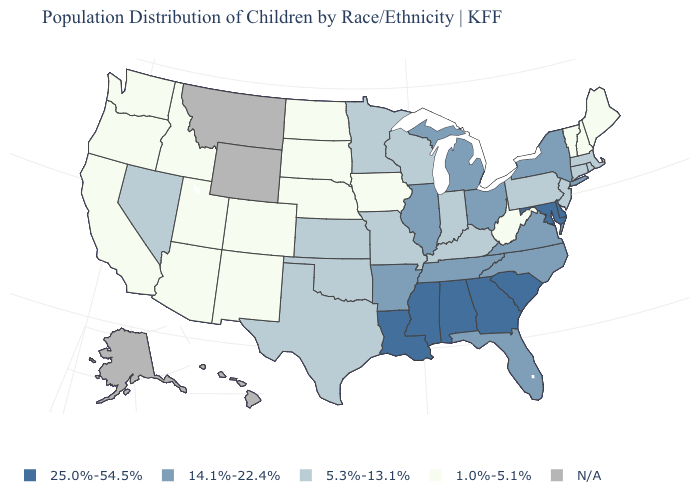What is the highest value in the West ?
Be succinct. 5.3%-13.1%. Name the states that have a value in the range 25.0%-54.5%?
Concise answer only. Alabama, Delaware, Georgia, Louisiana, Maryland, Mississippi, South Carolina. Which states have the highest value in the USA?
Write a very short answer. Alabama, Delaware, Georgia, Louisiana, Maryland, Mississippi, South Carolina. How many symbols are there in the legend?
Keep it brief. 5. What is the value of Oklahoma?
Answer briefly. 5.3%-13.1%. Which states have the lowest value in the MidWest?
Keep it brief. Iowa, Nebraska, North Dakota, South Dakota. What is the value of New York?
Give a very brief answer. 14.1%-22.4%. Does New York have the highest value in the USA?
Give a very brief answer. No. Does the map have missing data?
Answer briefly. Yes. Name the states that have a value in the range 5.3%-13.1%?
Concise answer only. Connecticut, Indiana, Kansas, Kentucky, Massachusetts, Minnesota, Missouri, Nevada, New Jersey, Oklahoma, Pennsylvania, Rhode Island, Texas, Wisconsin. Which states have the lowest value in the USA?
Write a very short answer. Arizona, California, Colorado, Idaho, Iowa, Maine, Nebraska, New Hampshire, New Mexico, North Dakota, Oregon, South Dakota, Utah, Vermont, Washington, West Virginia. Name the states that have a value in the range 25.0%-54.5%?
Answer briefly. Alabama, Delaware, Georgia, Louisiana, Maryland, Mississippi, South Carolina. Name the states that have a value in the range 14.1%-22.4%?
Be succinct. Arkansas, Florida, Illinois, Michigan, New York, North Carolina, Ohio, Tennessee, Virginia. What is the lowest value in states that border Alabama?
Quick response, please. 14.1%-22.4%. 